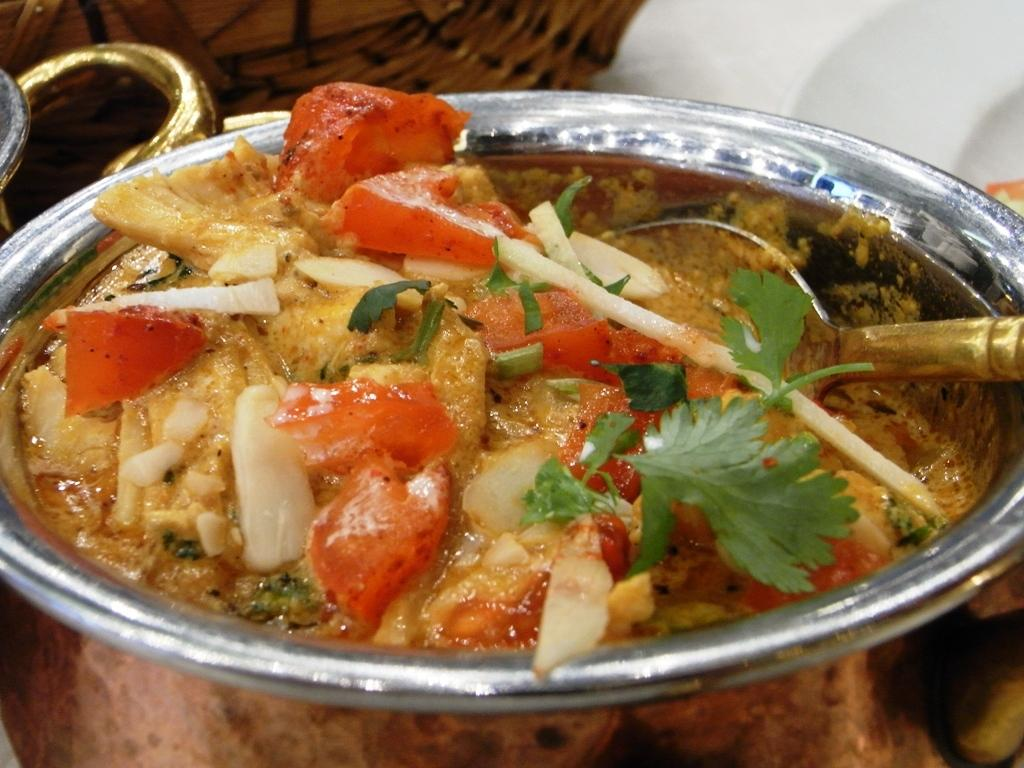What type of food item is in the image? The specific type of food item is not mentioned, but it is in a copper bowl. What is used to eat the food item in the image? There is a spoon in the copper bowl. What can be seen in the background of the image? There are objects in the background of the image, but their specific nature is not mentioned. What is the chance of winning a game at the playground in the image? There is no playground present in the image, so it is not possible to determine the chance of winning a game. 